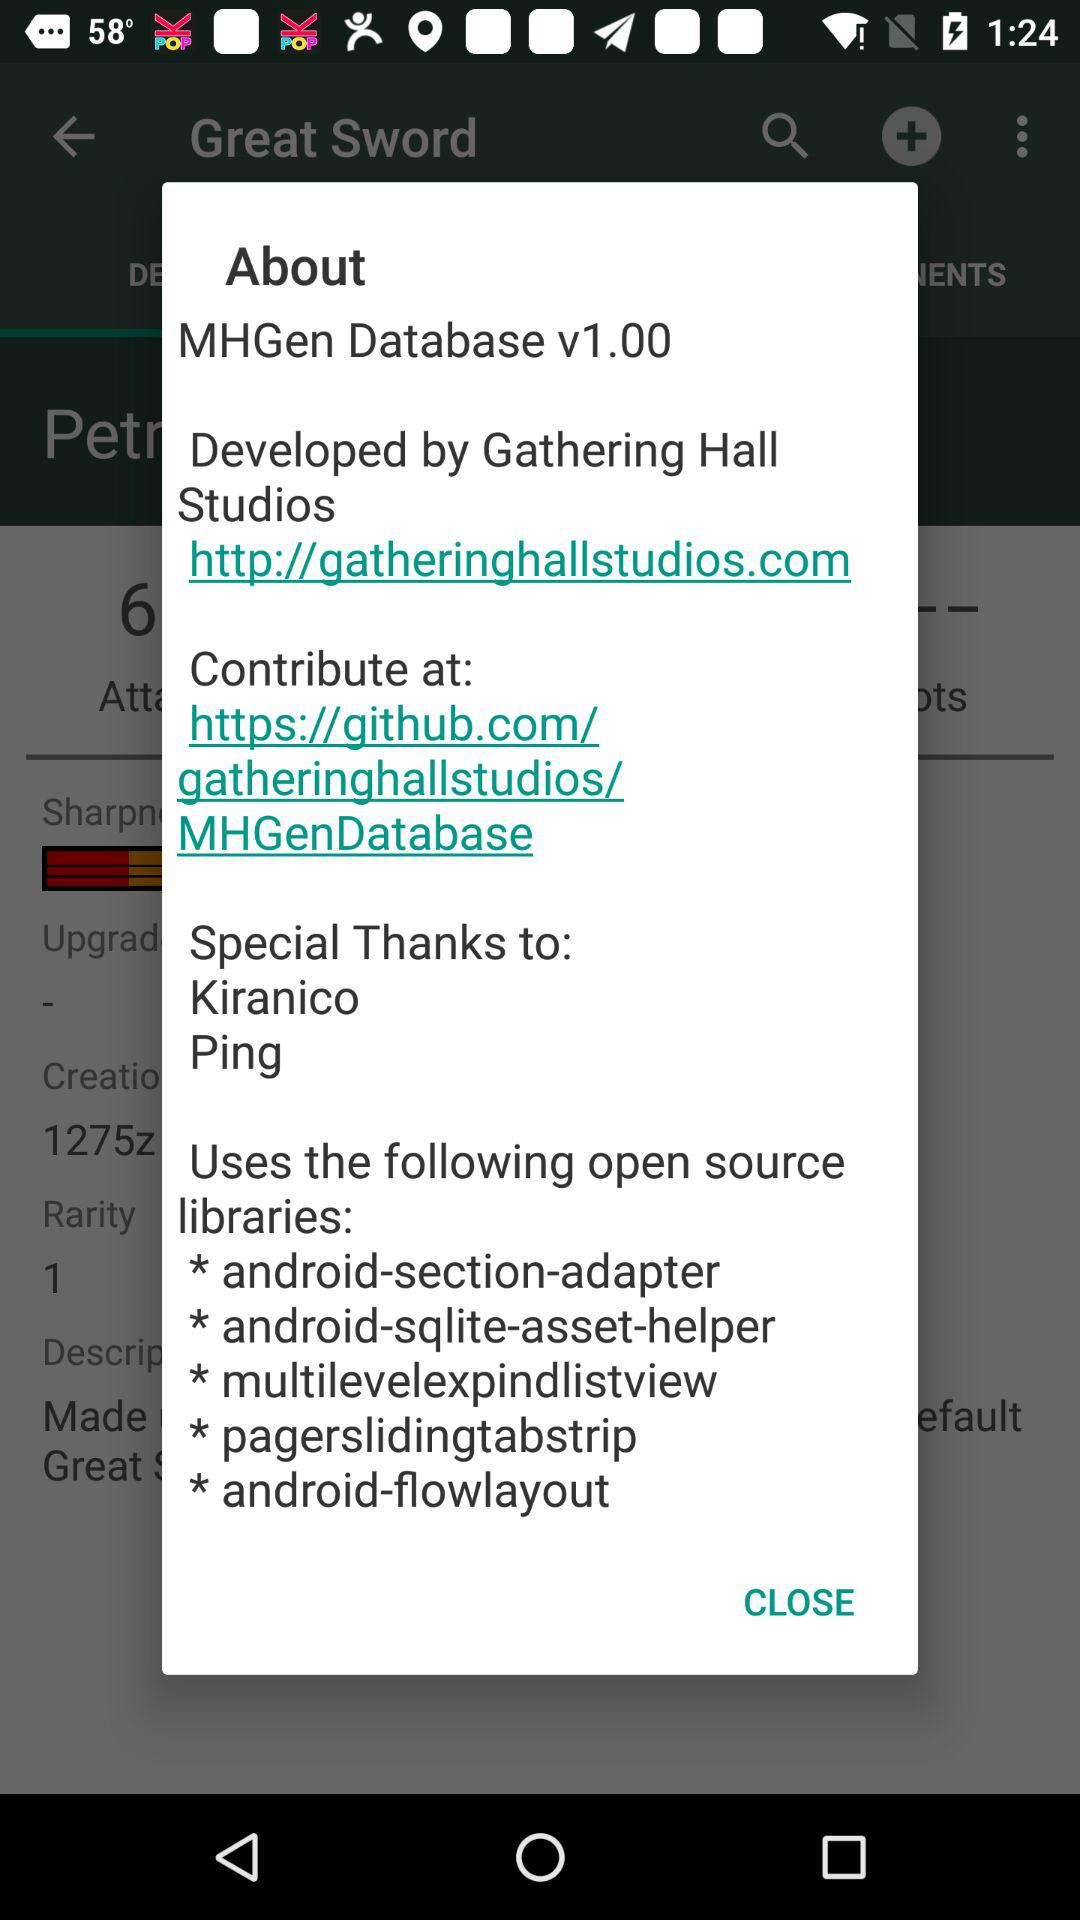How many open source libraries are used by the app?
Answer the question using a single word or phrase. 5 